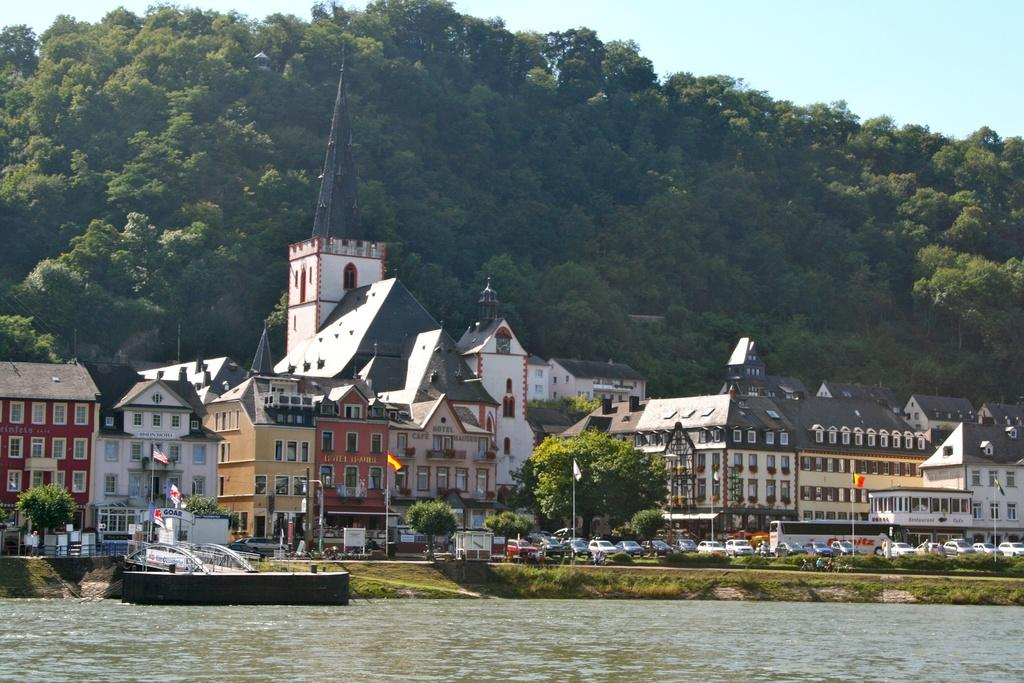What type of vegetation can be seen in the image? There are trees in the image. What type of structures are present in the image? There are houses in the image. What vehicles can be seen in the image? Cars are parked in the image, and a bus is moving on the road. What are the flag poles used for in the image? The flag poles are used to display flags. What type of infrastructure is present in the image? There is a foot over bridge in the image. What natural element is visible in the image? Water is visible in the image. What type of story is being told by the worm in the image? There is no worm present in the image, so no story can be told by a worm. Can you tell me the credit score of the person who owns the house in the image? There is no information about the credit score of the person who owns the house in the image. 